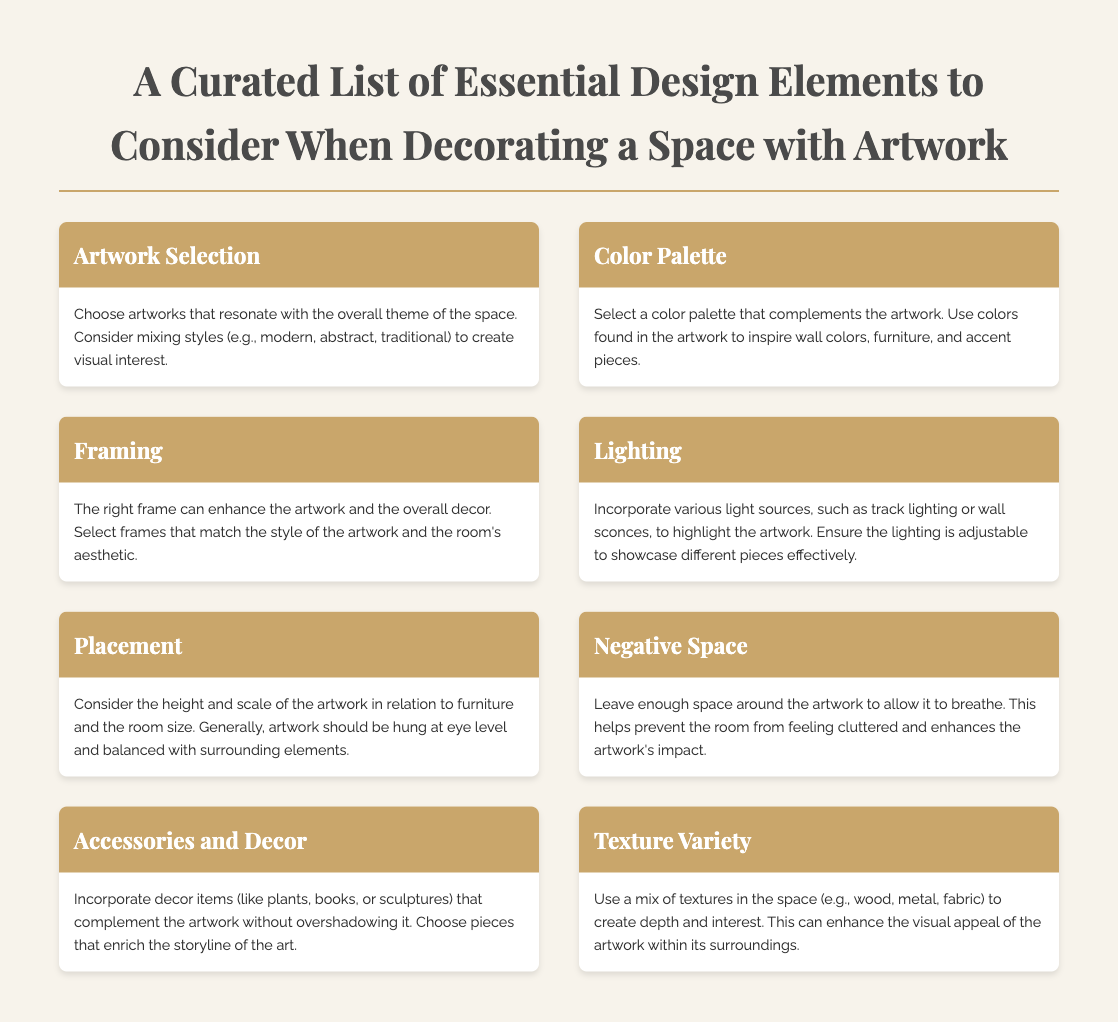what is the title of the document? The title is prominently displayed at the top of the document and summarizes the content, which is a curated list of essential design elements for decorating spaces with artwork.
Answer: A Curated List of Essential Design Elements to Consider When Decorating a Space with Artwork how many design elements are listed in the document? The document contains a menu with eight design elements that are crucial when decorating a space with artwork.
Answer: 8 what are the contents of the “Framing” section? The "Framing" section discusses the importance of selecting frames that enhance both the artwork and the overall decor, matching their styles.
Answer: The right frame can enhance the artwork and the overall decor. Select frames that match the style of the artwork and the room's aesthetic what is meant by "Negative Space" in the context of art placement? The “Negative Space” section emphasizes leaving space around the artwork to allow it to breathe, avoiding a cluttered feeling in the room.
Answer: Leave enough space around the artwork to allow it to breathe which design element involves using various light sources? The "Lighting" section addresses the incorporation of various light sources to highlight artwork, providing the flexibility to showcase different pieces.
Answer: Lighting what is suggested for placement of artwork in relation to furniture? The document advises that artwork should be hung at eye level and balanced with surrounding elements, considering height and scale.
Answer: At eye level which aspect of design does "Texture Variety" refer to? The "Texture Variety" portion refers to using a mix of materials like wood, metal, and fabric to create depth and visual interest in the space.
Answer: A mix of textures what decorative items should be incorporated alongside artwork? The "Accessories and Decor" section suggests incorporating decor items such as plants, books, or sculptures that complement the artwork without overshadowing it.
Answer: Plants, books, or sculptures 